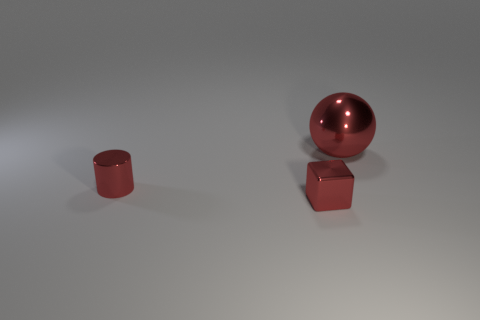What can you infer about the surface the objects are on? The surface upon which the objects rest is smooth and has a subtle reflection, hinting at a relatively non-porous or polished material. This level sheen suggests it could be a treated material like laminated wood or coated metal, common in a studio or display environment. 